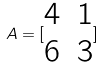Convert formula to latex. <formula><loc_0><loc_0><loc_500><loc_500>A = [ \begin{matrix} 4 & 1 \\ 6 & 3 \end{matrix} ]</formula> 